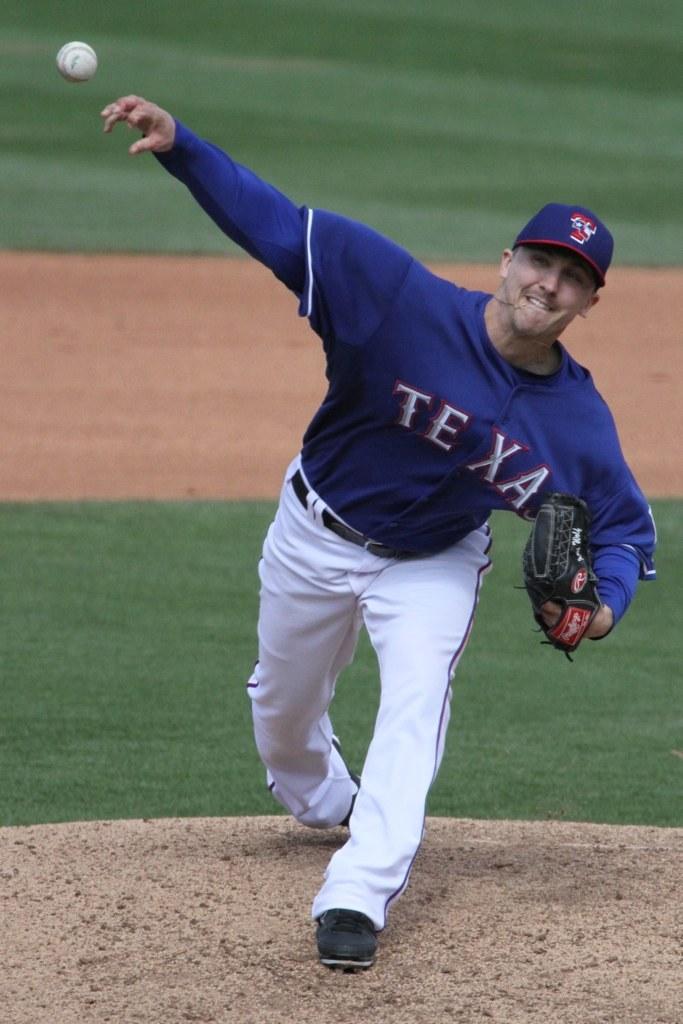What is the team on the players shirt?
Offer a terse response. Texas. 